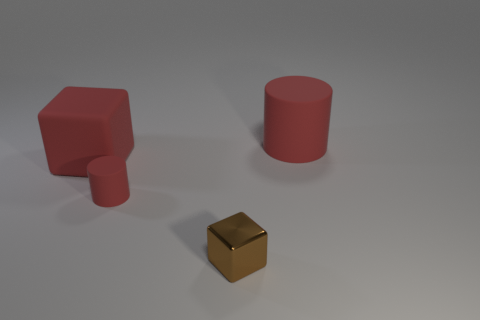Can you tell me the shapes and colors of the objects in the image? Certainly! The image displays three objects: a red cube, a red cylinder, and a small brown cube. The red cube and cylinder have a uniform matte red color, whereas the smaller cube has a reflective brown surface, indicating it might be made of a different material like metal. 